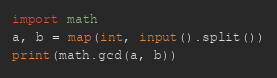<code> <loc_0><loc_0><loc_500><loc_500><_Python_>import math
a, b = map(int, input().split())
print(math.gcd(a, b))</code> 